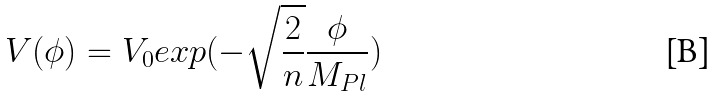Convert formula to latex. <formula><loc_0><loc_0><loc_500><loc_500>V ( \phi ) = V _ { 0 } e x p ( - \sqrt { \frac { 2 } { n } } \frac { \phi } { M _ { P l } } )</formula> 